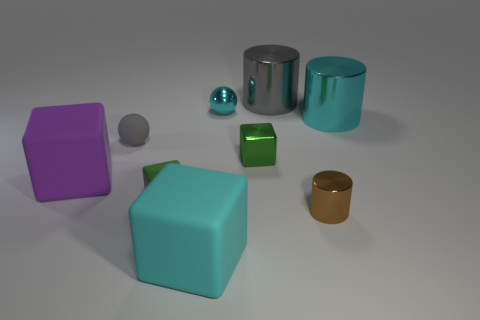What is the size of the green object that is right of the small matte object that is in front of the purple cube?
Your response must be concise. Small. Does the tiny matte object that is to the right of the tiny gray thing have the same color as the shiny cube?
Your response must be concise. Yes. Is the number of cyan metallic things that are on the left side of the green matte object less than the number of tiny green metal things?
Provide a succinct answer. Yes. What shape is the gray thing that is made of the same material as the large cyan cylinder?
Your answer should be compact. Cylinder. Does the big purple thing have the same material as the large cyan block?
Your response must be concise. Yes. Are there fewer brown cylinders in front of the small brown cylinder than blocks to the right of the tiny cyan ball?
Keep it short and to the point. Yes. What is the size of the block that is the same color as the small metal ball?
Your answer should be compact. Large. How many metal objects are behind the big thing that is to the right of the big thing that is behind the cyan metallic sphere?
Offer a very short reply. 2. Is the metal block the same color as the small matte block?
Give a very brief answer. Yes. Are there any big matte cylinders of the same color as the small metallic ball?
Provide a short and direct response. No. 